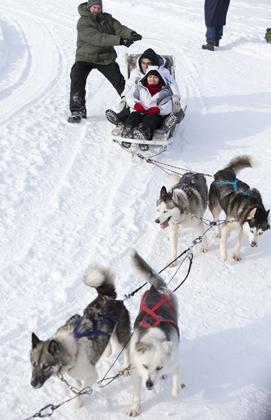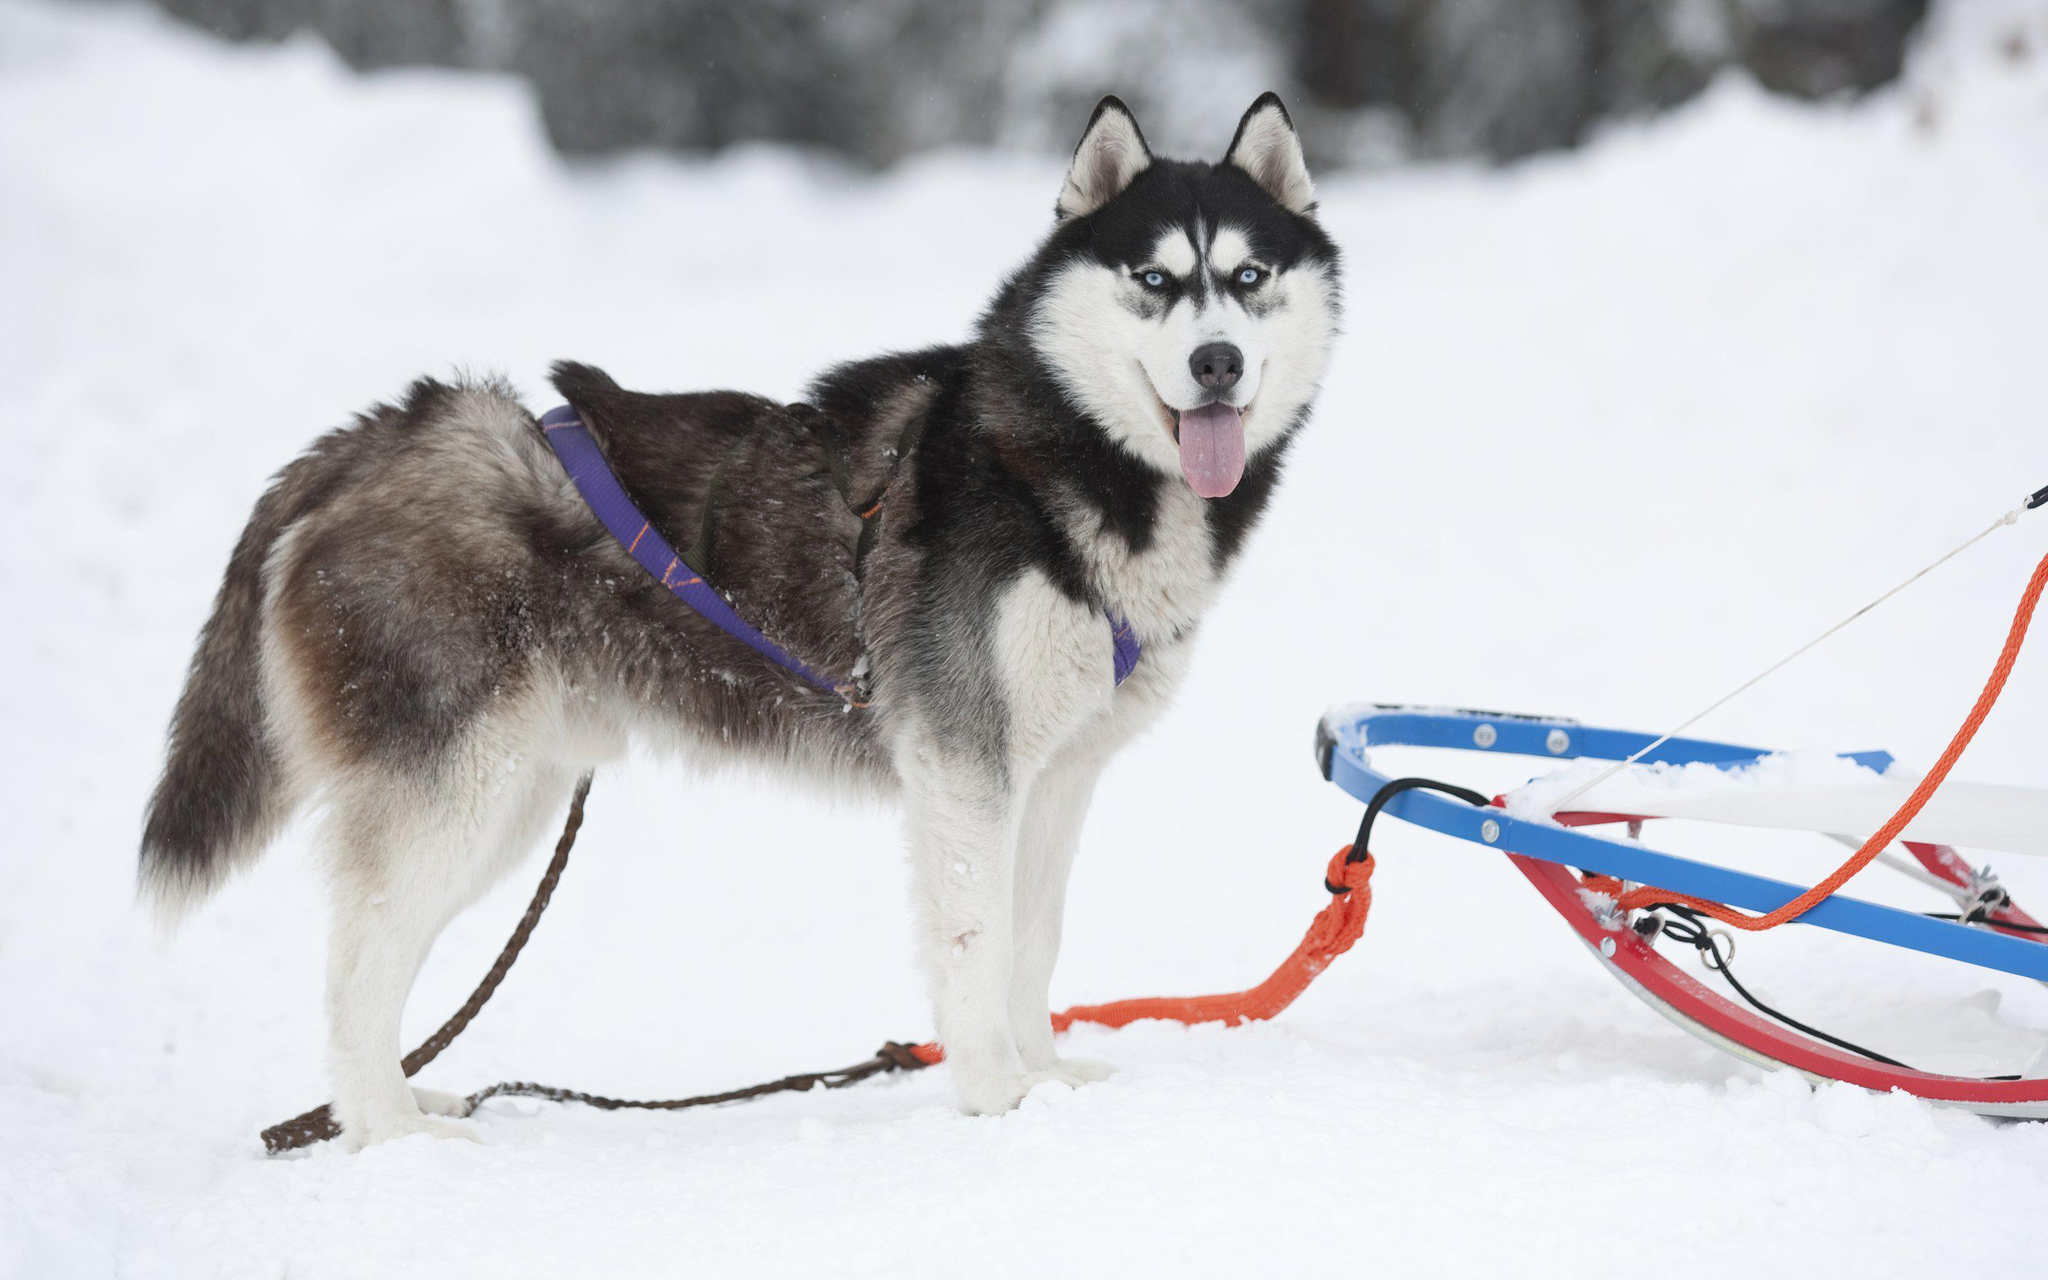The first image is the image on the left, the second image is the image on the right. Given the left and right images, does the statement "There are people in both images." hold true? Answer yes or no. No. The first image is the image on the left, the second image is the image on the right. Considering the images on both sides, is "The dog team in the left image is headed forward in a straight path, while the dog team in the right image has veered to the right." valid? Answer yes or no. No. 